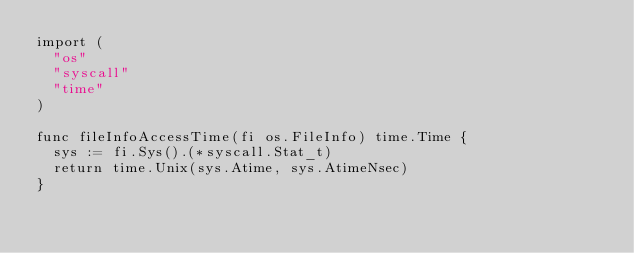<code> <loc_0><loc_0><loc_500><loc_500><_Go_>import (
	"os"
	"syscall"
	"time"
)

func fileInfoAccessTime(fi os.FileInfo) time.Time {
	sys := fi.Sys().(*syscall.Stat_t)
	return time.Unix(sys.Atime, sys.AtimeNsec)
}
</code> 